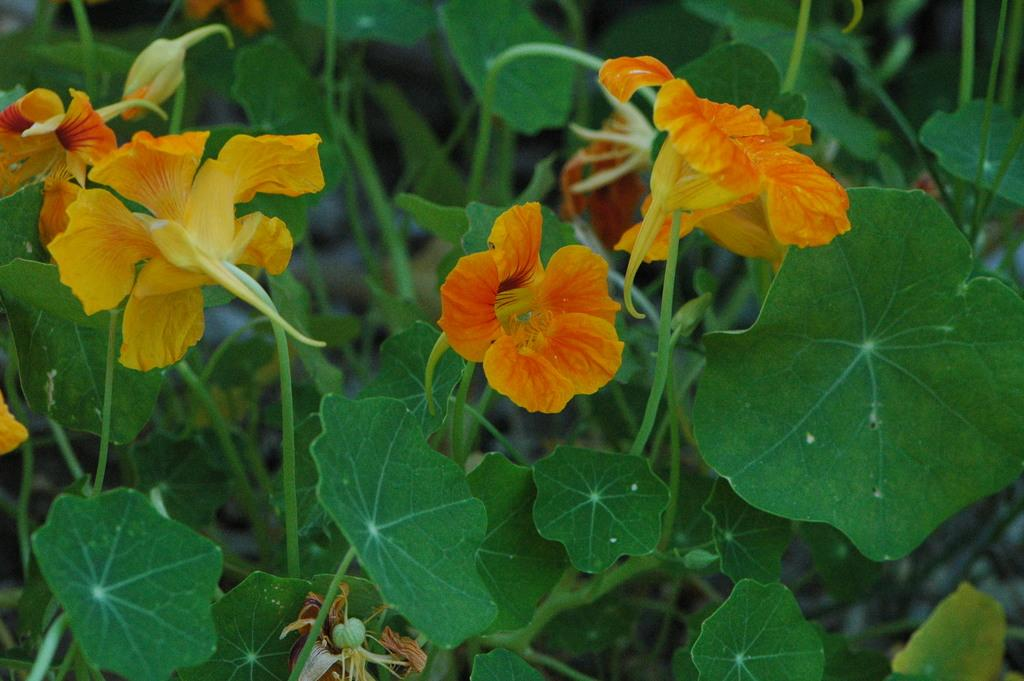What type of living organisms can be seen in the image? Plants can be seen in the image. What color are the flowers on the plants? The flowers on the plants are yellow. What type of skirt is hanging on the nail in the image? There is no skirt or nail present in the image; it only features plants with yellow flowers. 